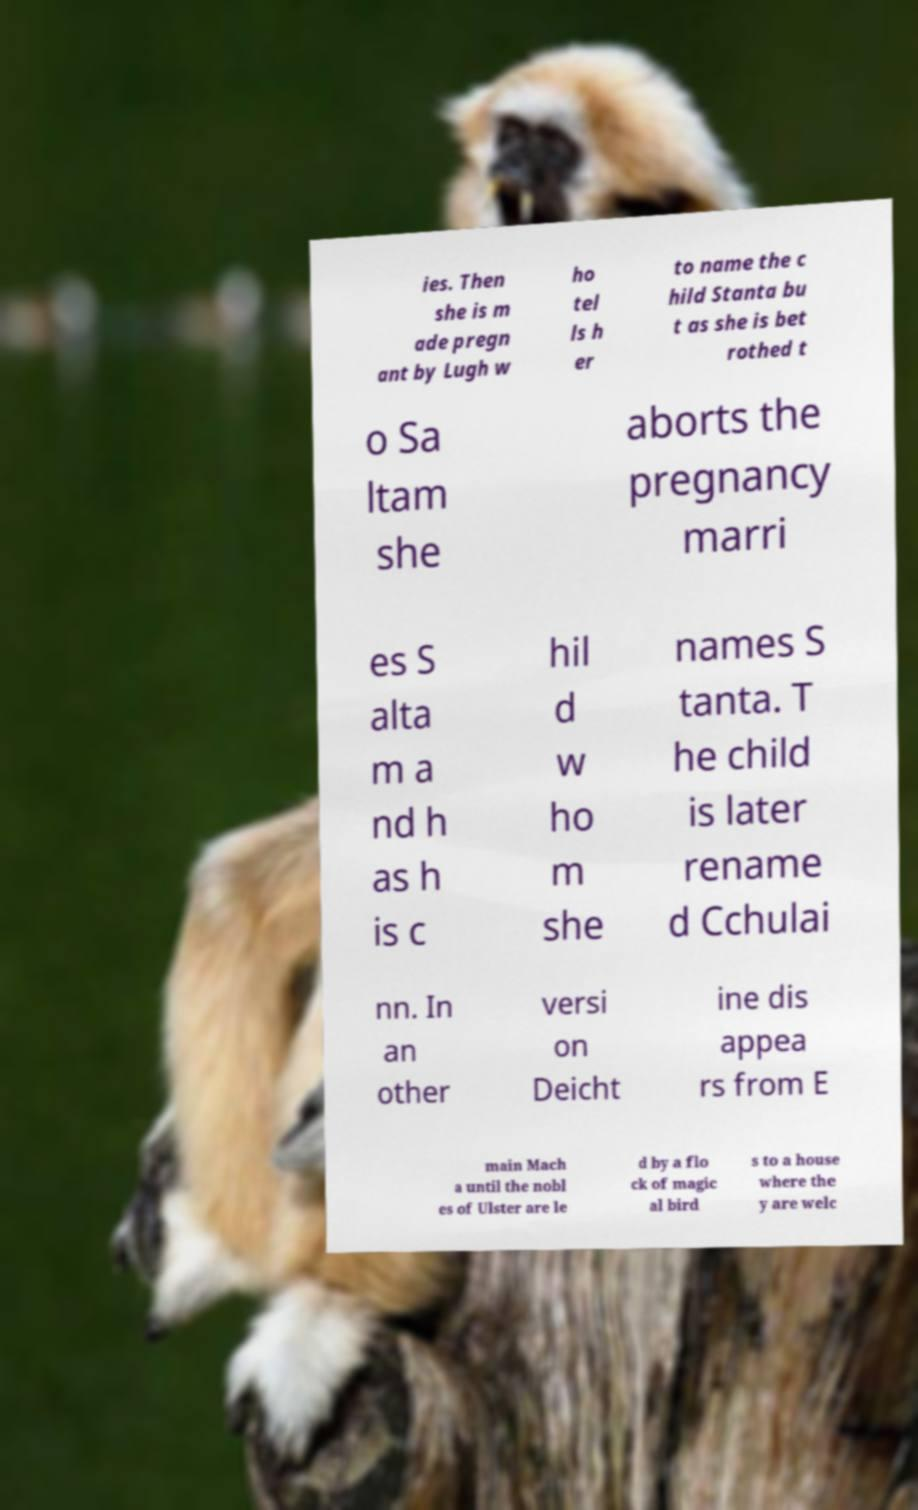Could you assist in decoding the text presented in this image and type it out clearly? ies. Then she is m ade pregn ant by Lugh w ho tel ls h er to name the c hild Stanta bu t as she is bet rothed t o Sa ltam she aborts the pregnancy marri es S alta m a nd h as h is c hil d w ho m she names S tanta. T he child is later rename d Cchulai nn. In an other versi on Deicht ine dis appea rs from E main Mach a until the nobl es of Ulster are le d by a flo ck of magic al bird s to a house where the y are welc 